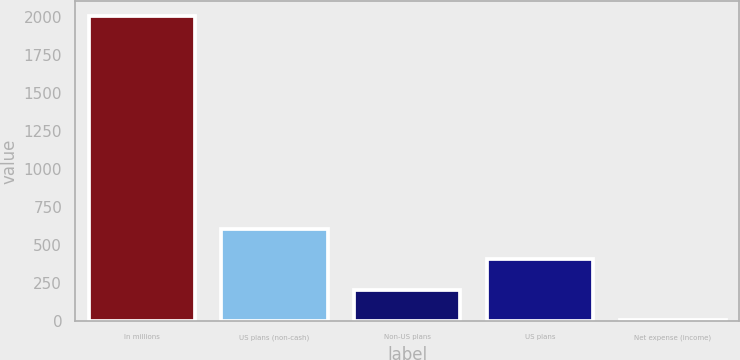Convert chart. <chart><loc_0><loc_0><loc_500><loc_500><bar_chart><fcel>In millions<fcel>US plans (non-cash)<fcel>Non-US plans<fcel>US plans<fcel>Net expense (income)<nl><fcel>2002<fcel>604.1<fcel>204.7<fcel>404.4<fcel>5<nl></chart> 